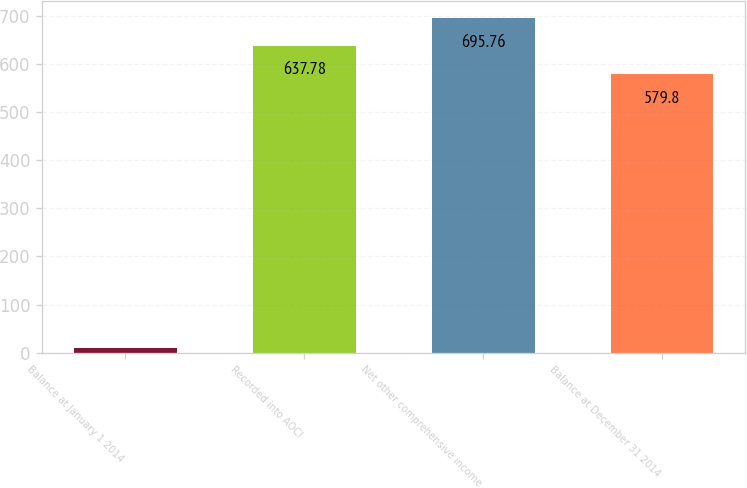Convert chart. <chart><loc_0><loc_0><loc_500><loc_500><bar_chart><fcel>Balance at January 1 2014<fcel>Recorded into AOCI<fcel>Net other comprehensive income<fcel>Balance at December 31 2014<nl><fcel>8.7<fcel>637.78<fcel>695.76<fcel>579.8<nl></chart> 